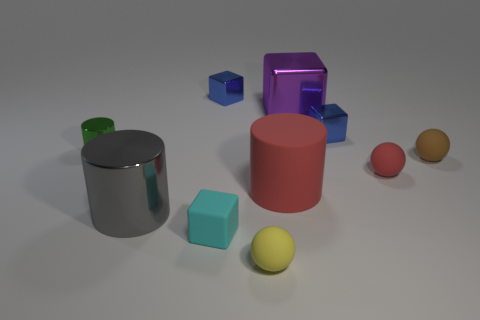Subtract all large blocks. How many blocks are left? 3 Subtract all purple cubes. How many cubes are left? 3 Subtract all yellow cylinders. How many blue blocks are left? 2 Subtract 0 purple spheres. How many objects are left? 10 Subtract all cylinders. How many objects are left? 7 Subtract 2 cylinders. How many cylinders are left? 1 Subtract all brown blocks. Subtract all gray cylinders. How many blocks are left? 4 Subtract all tiny red matte things. Subtract all brown things. How many objects are left? 8 Add 5 large shiny blocks. How many large shiny blocks are left? 6 Add 1 large shiny cylinders. How many large shiny cylinders exist? 2 